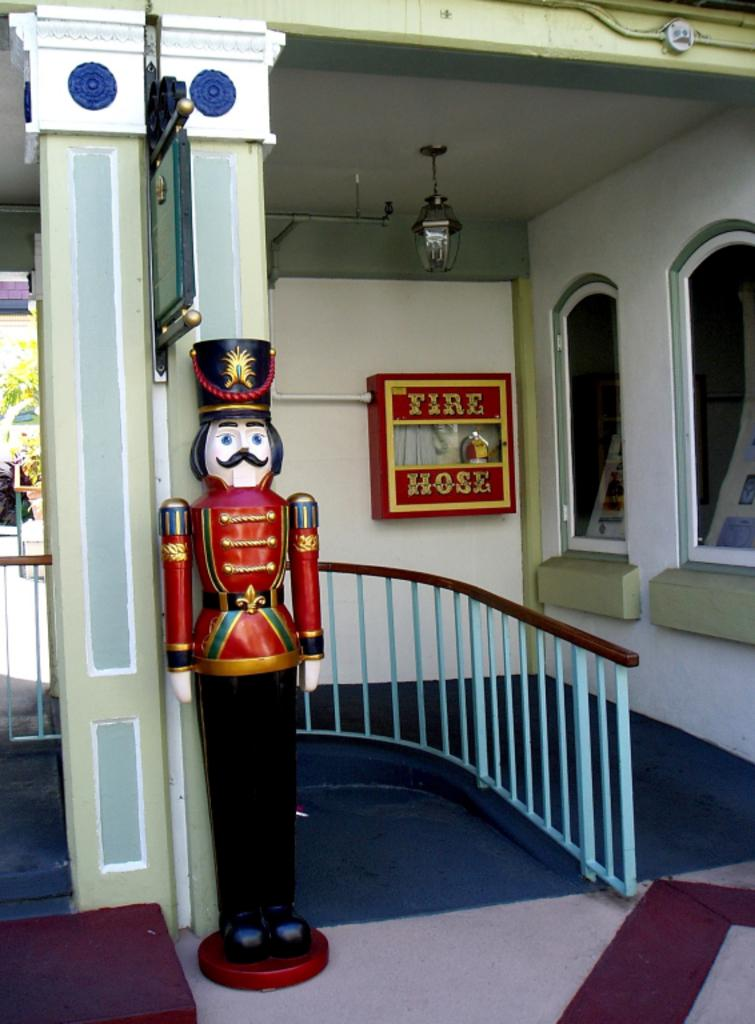What is the main subject in the image? There is a statue in the image. What is the statue shaped like? The statue is in the shape of a fireman. What is associated with the statue in the image? There is a fire hose associated with the statue. Reasoning: Let's think step by step in order to produce the conversation. We start by identifying the main subject in the image, which is the statue. Then, we expand the conversation to include the shape of the statue, which is a fireman. Finally, we mention the fire hose associated with the statue. Each question is designed to elicit a specific detail about the image that is known from the provided facts. Absurd Question/Answer: How many cakes are on the statue's head in the image? There are no cakes present in the image, as the statue is a fireman holding a fire hose. --- Facts: 1. There is a person in the image. 2. The person is wearing a hat. 3. The person is holding a book. 4. There is a tree in the background of the image. Absurd Topics: bicycle, ocean, parrot Conversation: What is the main subject in the image? There is a person in 